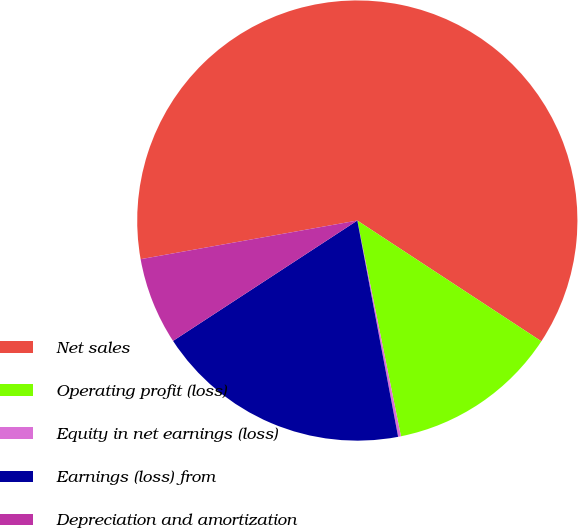<chart> <loc_0><loc_0><loc_500><loc_500><pie_chart><fcel>Net sales<fcel>Operating profit (loss)<fcel>Equity in net earnings (loss)<fcel>Earnings (loss) from<fcel>Depreciation and amortization<nl><fcel>62.05%<fcel>12.58%<fcel>0.21%<fcel>18.76%<fcel>6.4%<nl></chart> 